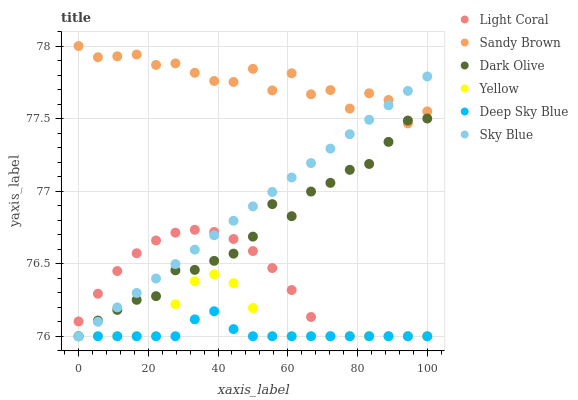Does Deep Sky Blue have the minimum area under the curve?
Answer yes or no. Yes. Does Sandy Brown have the maximum area under the curve?
Answer yes or no. Yes. Does Yellow have the minimum area under the curve?
Answer yes or no. No. Does Yellow have the maximum area under the curve?
Answer yes or no. No. Is Sky Blue the smoothest?
Answer yes or no. Yes. Is Sandy Brown the roughest?
Answer yes or no. Yes. Is Yellow the smoothest?
Answer yes or no. No. Is Yellow the roughest?
Answer yes or no. No. Does Dark Olive have the lowest value?
Answer yes or no. Yes. Does Sandy Brown have the lowest value?
Answer yes or no. No. Does Sandy Brown have the highest value?
Answer yes or no. Yes. Does Yellow have the highest value?
Answer yes or no. No. Is Deep Sky Blue less than Sandy Brown?
Answer yes or no. Yes. Is Sandy Brown greater than Light Coral?
Answer yes or no. Yes. Does Deep Sky Blue intersect Light Coral?
Answer yes or no. Yes. Is Deep Sky Blue less than Light Coral?
Answer yes or no. No. Is Deep Sky Blue greater than Light Coral?
Answer yes or no. No. Does Deep Sky Blue intersect Sandy Brown?
Answer yes or no. No. 